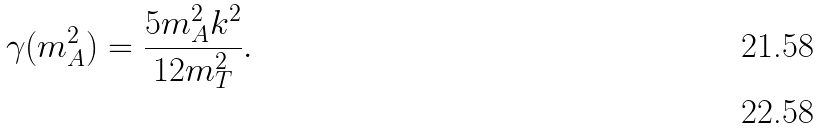Convert formula to latex. <formula><loc_0><loc_0><loc_500><loc_500>\gamma ( m ^ { 2 } _ { A } ) = \frac { 5 m ^ { 2 } _ { A } k ^ { 2 } } { 1 2 m _ { T } ^ { 2 } } . \\</formula> 